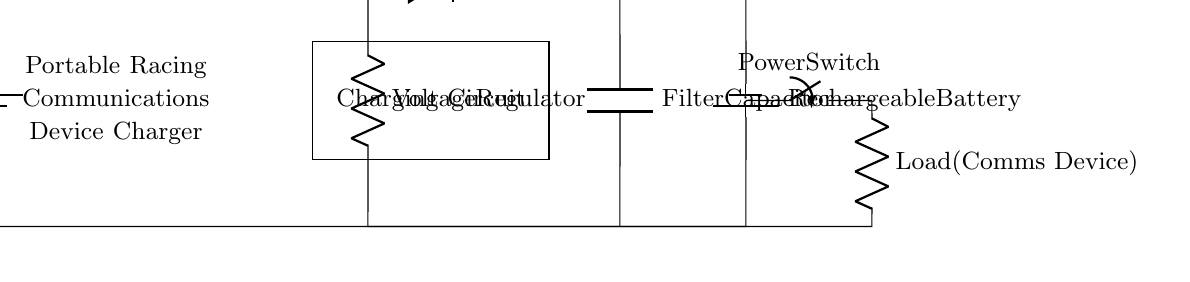What is the type of the input voltage source? The input voltage source is labeled as a battery1, indicating it's a battery type power supply providing direct current.
Answer: battery What component is used to regulate voltage? The voltage regulator is specifically shown in the circuit, ensuring the output voltage remains constant despite variations in input voltage or load current.
Answer: Voltage Regulator What is the purpose of the protection diode? The protection diode is used to prevent reverse current flow, protecting the components upstream from damage when the battery gets charged.
Answer: prevent reverse current How many rechargeable batteries are illustrated in the circuit? There is one rechargeable battery indicated in the circuit, specifically labeled as Rechargeable Battery, located towards the bottom right of the diagram.
Answer: one What is the primary function of the filter capacitor in this circuit? The filter capacitor smoothens the output voltage by reducing voltage ripple, ensuring stable power delivery to the communications device.
Answer: smoothens output voltage What is the role of the current limiter in this charging circuit? The current limiter restricts the amount of current flowing into the battery during charging, preventing overcurrent situations which could damage the battery.
Answer: restricts current 